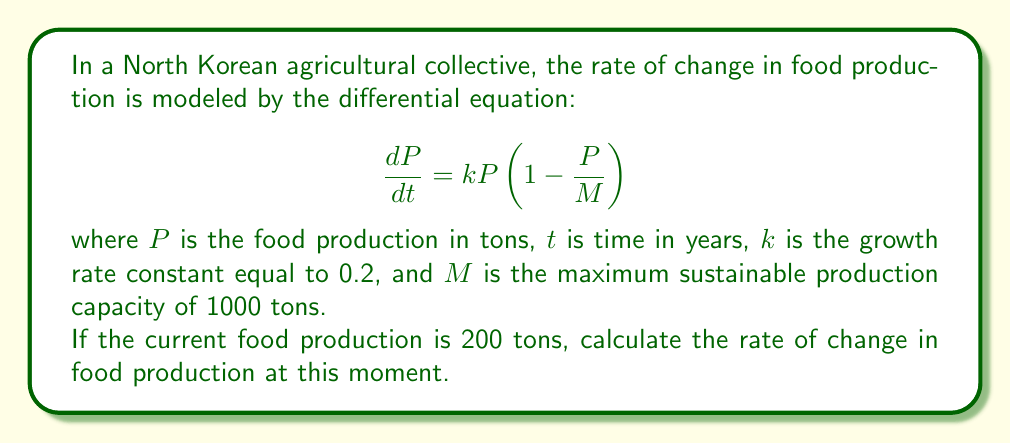Can you solve this math problem? To solve this problem, we need to use the given first-order differential equation and substitute the known values:

1. Given equation: $\frac{dP}{dt} = kP(1 - \frac{P}{M})$

2. Known values:
   $k = 0.2$
   $M = 1000$ tons
   $P = 200$ tons (current production)

3. Substitute these values into the equation:

   $$\frac{dP}{dt} = 0.2 \cdot 200 \cdot (1 - \frac{200}{1000})$$

4. Simplify:
   $$\frac{dP}{dt} = 40 \cdot (1 - 0.2)$$
   $$\frac{dP}{dt} = 40 \cdot 0.8$$
   $$\frac{dP}{dt} = 32$$

Therefore, the rate of change in food production at this moment is 32 tons per year.
Answer: The rate of change in food production is 32 tons per year. 